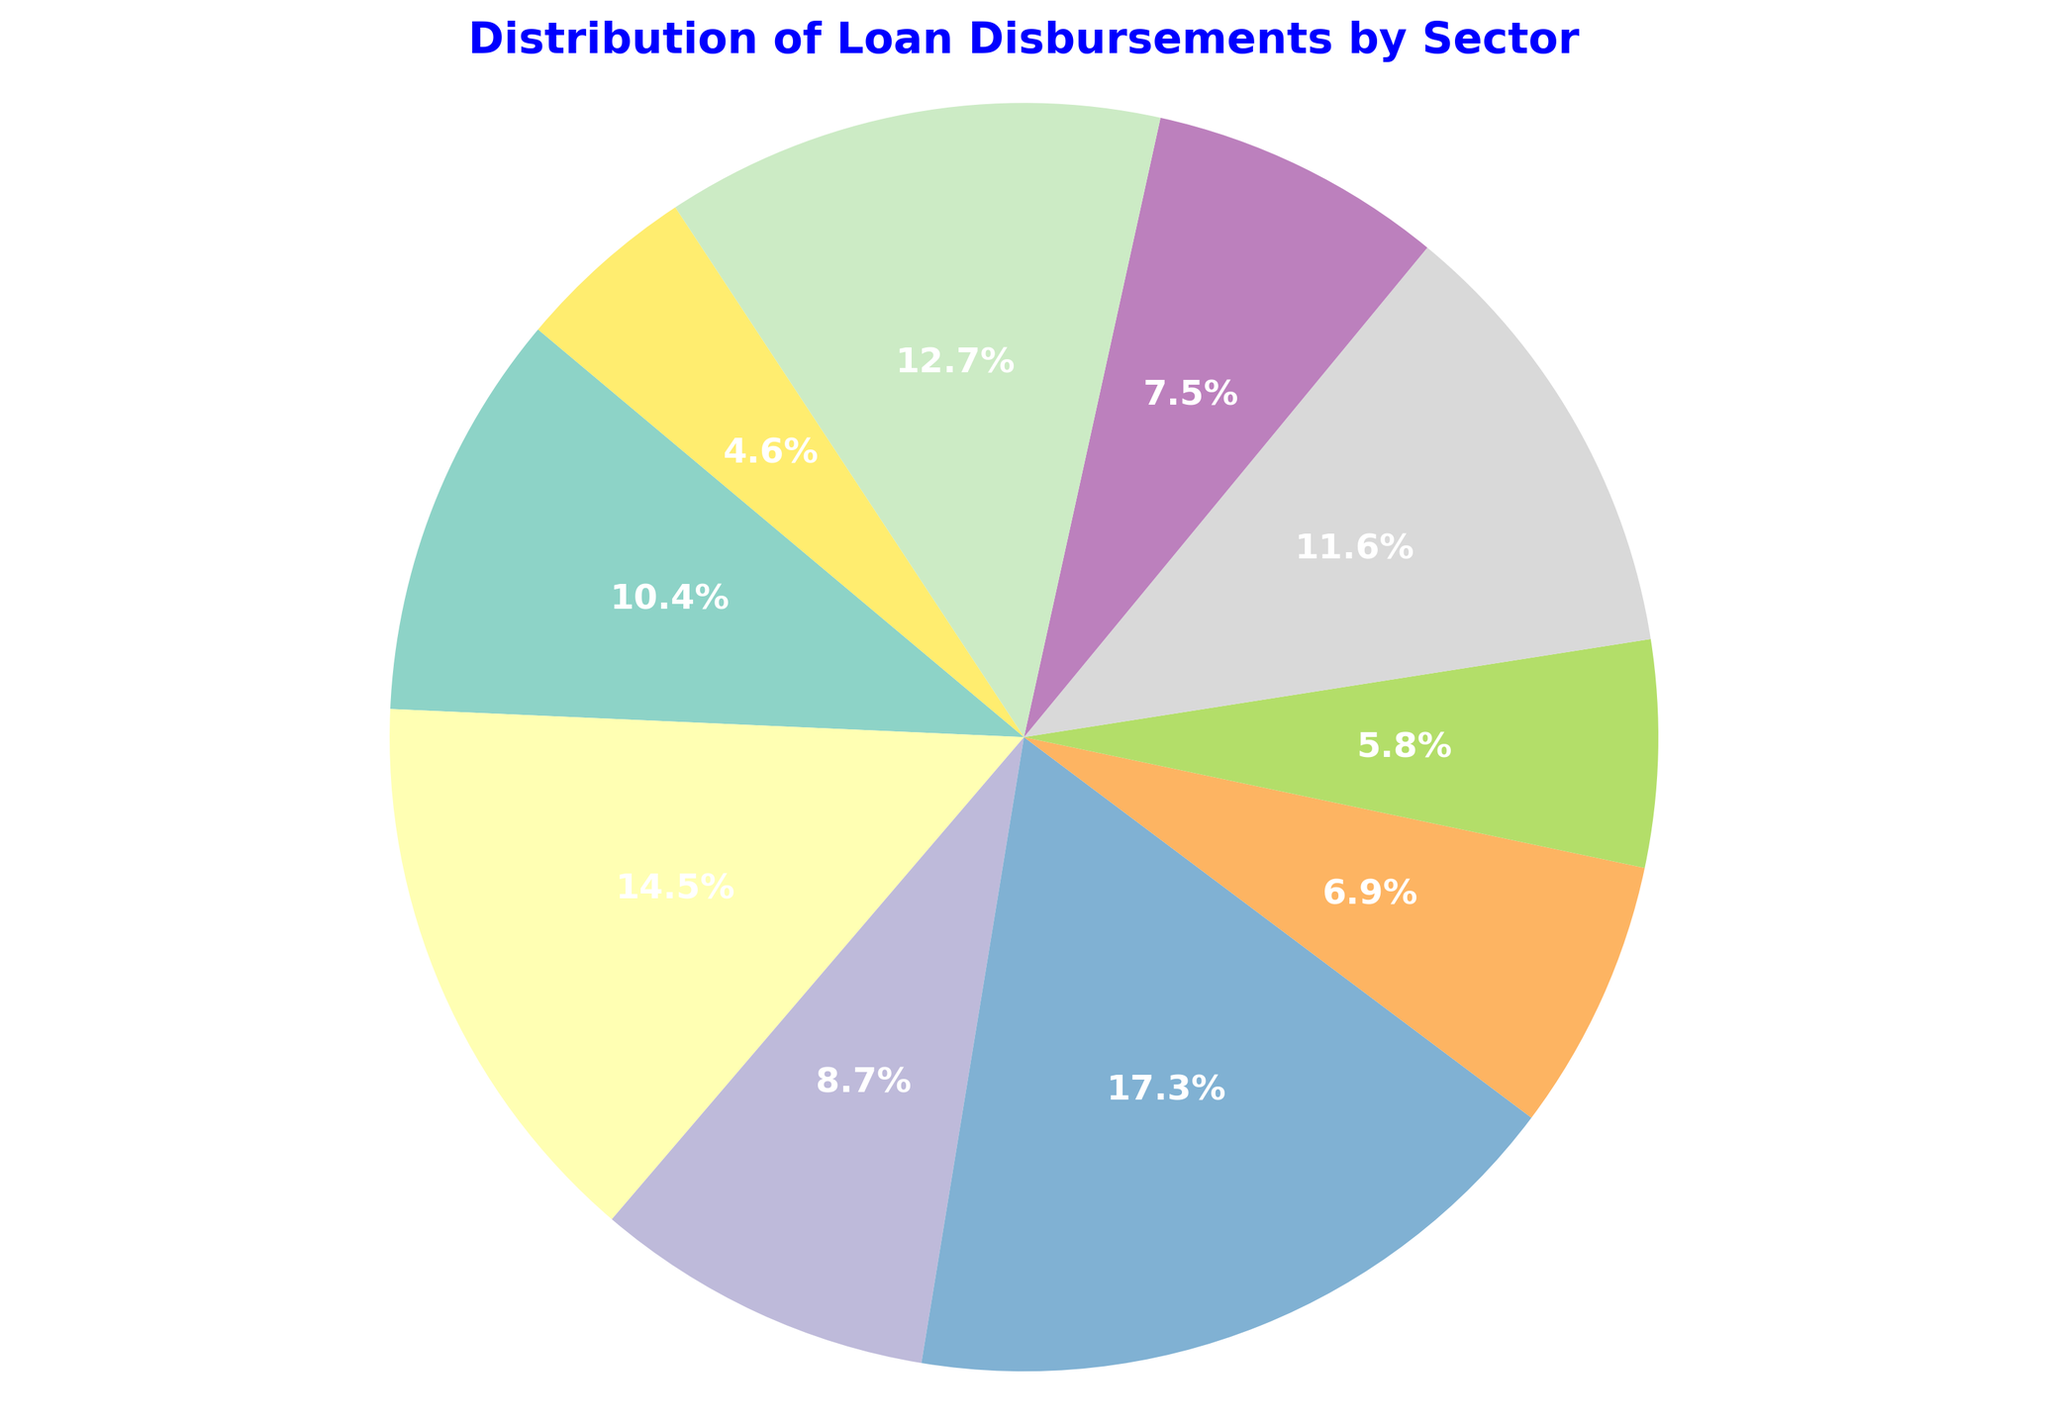Which sector has received the highest loan disbursement? By looking at the pie chart, we can identify the sector with the largest slice. The largest slice corresponds to Infrastructure.
Answer: Infrastructure What is the combined percentage of loan disbursements for the Healthcare and Transport sectors? First, locate the slices for Healthcare and Transport. Healthcare has 25% and Transport has 22%. Adding these together: 25% + 22% = 47%.
Answer: 47% Which sector has disbursements closest in size to Technology? We compare the size of the Technology slice (12%) with other slices. The Agriculture sector, having 18%, is the closest in size.
Answer: Agriculture What fraction of the total loan disbursements is allocated to Education and Social Services combined? Education is 15% and Social Services is 8%. Combining these: 15% + 8% = 23%. Hence, the fraction is 23%, or 23/100 = 0.23.
Answer: 0.23 Which sectors have disbursements equal to or greater than 20%? By examining the chart, the sectors with disbursements equal to or greater than 20% are Healthcare (25%), Infrastructure (30%), and Energy (20%).
Answer: Healthcare, Infrastructure, Energy Is the disbursement to Agriculture greater than the disbursement to Technology? We check the chart where Agriculture has 18% and Technology has 12%. Since 18% > 12%, the disbursement to Agriculture is greater.
Answer: Yes What is the total percentage of disbursements allocated to Infrastructure, Energy, and Healthcare sectors? Identify each sector's percentage: Infrastructure has 30%, Energy has 20%, and Healthcare has 25%. Adding these together: 30% + 20% + 25% = 75%.
Answer: 75% Are there any sectors with disbursements less than 10%? We locate the sectors with slices less than 10%. Only Social Services with 8% fits this criterion.
Answer: Social Services What is the difference in loan disbursement percentage between Energy and Water and Sanitation sectors? Energy has 20% and Water and Sanitation has 13%. The difference is 20% - 13% = 7%.
Answer: 7% Which sector has the smallest loan disbursement, and what is the percentage? From the chart, the smallest slice is observed for Social Services, which has 8%.
Answer: Social Services, 8% 